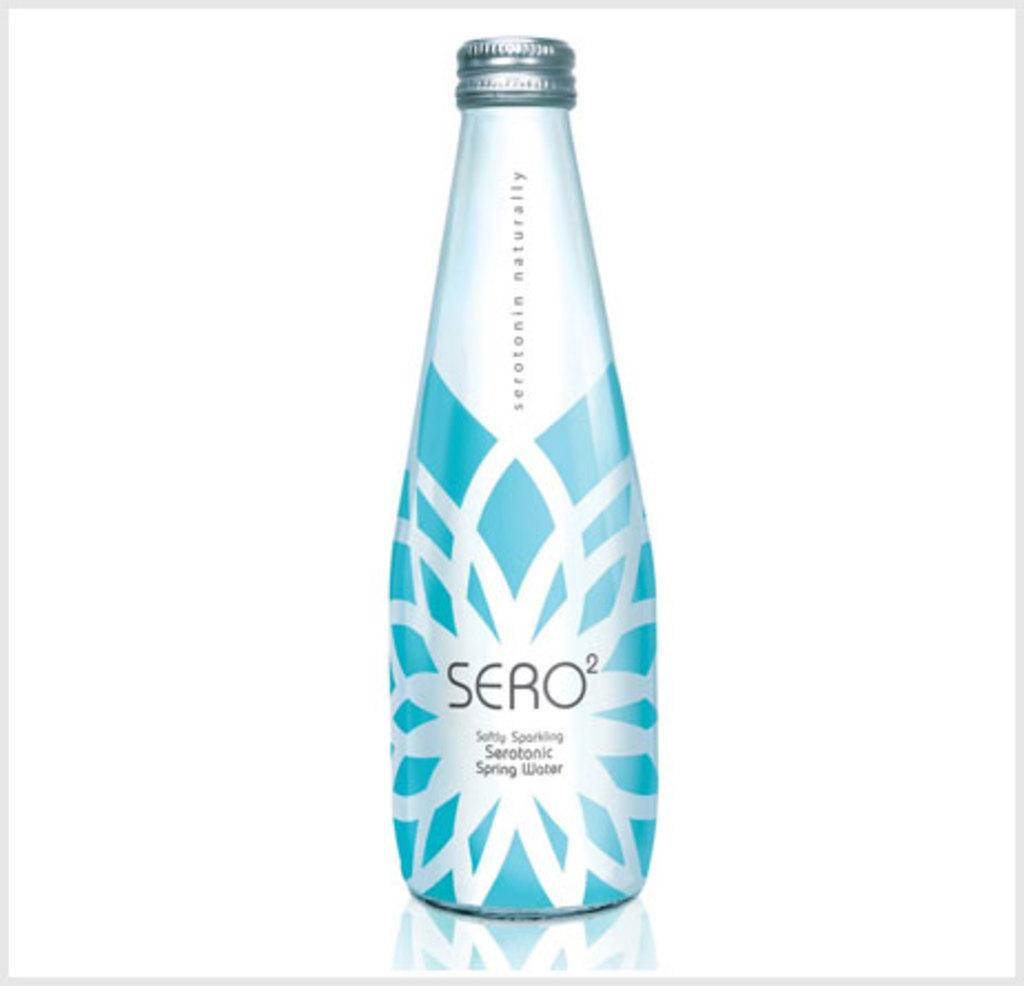<image>
Share a concise interpretation of the image provided. Blue and white bottle of Sero2 in front of a white background. 